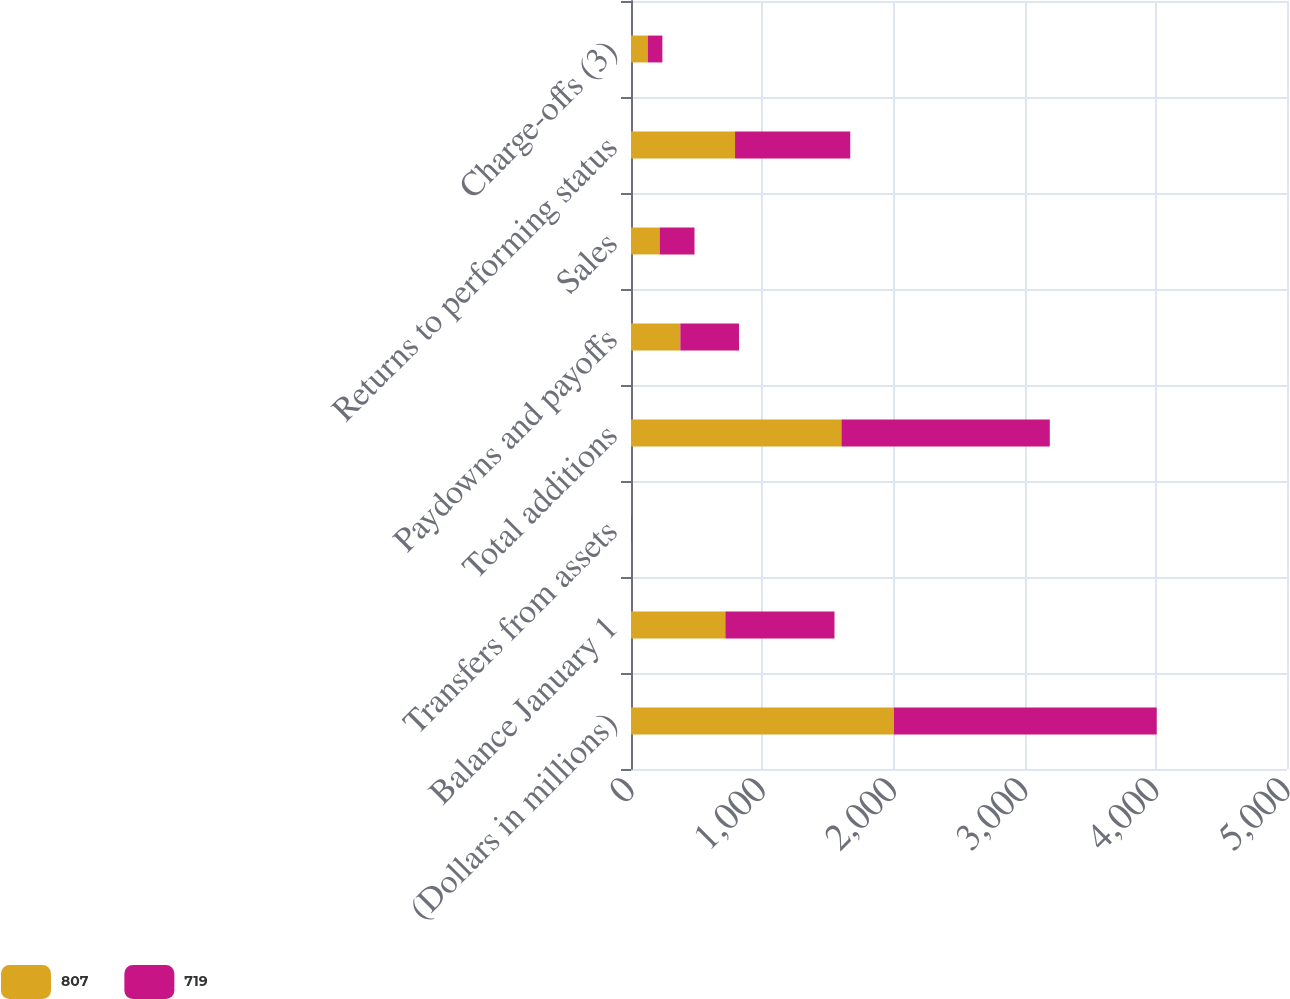Convert chart. <chart><loc_0><loc_0><loc_500><loc_500><stacked_bar_chart><ecel><fcel>(Dollars in millions)<fcel>Balance January 1<fcel>Transfers from assets<fcel>Total additions<fcel>Paydowns and payoffs<fcel>Sales<fcel>Returns to performing status<fcel>Charge-offs (3)<nl><fcel>807<fcel>2004<fcel>719<fcel>1<fcel>1604<fcel>376<fcel>219<fcel>793<fcel>128<nl><fcel>719<fcel>2003<fcel>832<fcel>5<fcel>1588<fcel>447<fcel>265<fcel>878<fcel>111<nl></chart> 